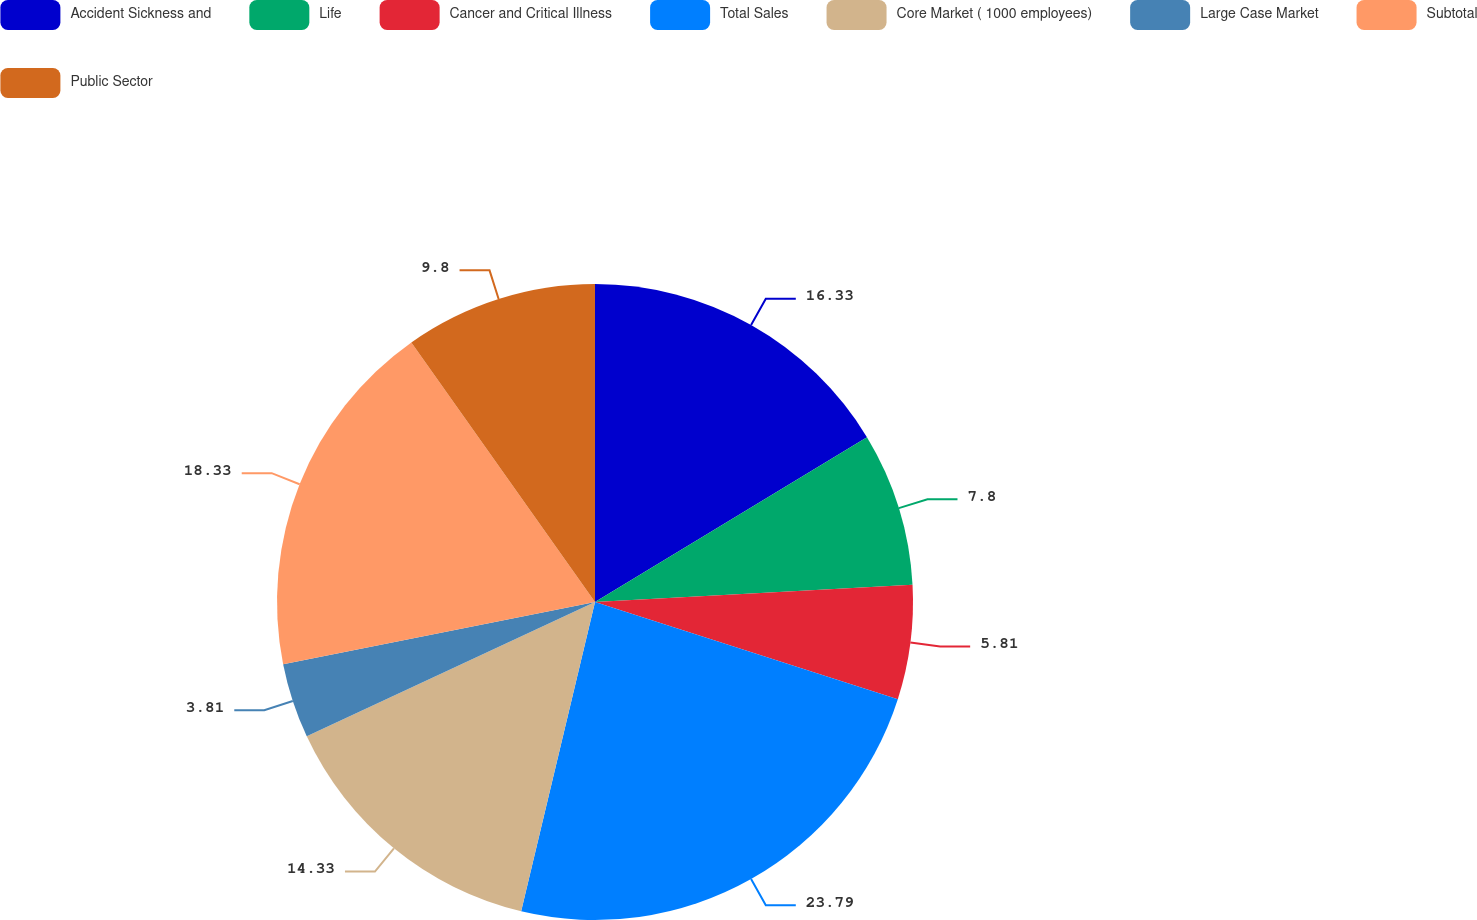Convert chart. <chart><loc_0><loc_0><loc_500><loc_500><pie_chart><fcel>Accident Sickness and<fcel>Life<fcel>Cancer and Critical Illness<fcel>Total Sales<fcel>Core Market ( 1000 employees)<fcel>Large Case Market<fcel>Subtotal<fcel>Public Sector<nl><fcel>16.33%<fcel>7.8%<fcel>5.81%<fcel>23.79%<fcel>14.33%<fcel>3.81%<fcel>18.33%<fcel>9.8%<nl></chart> 